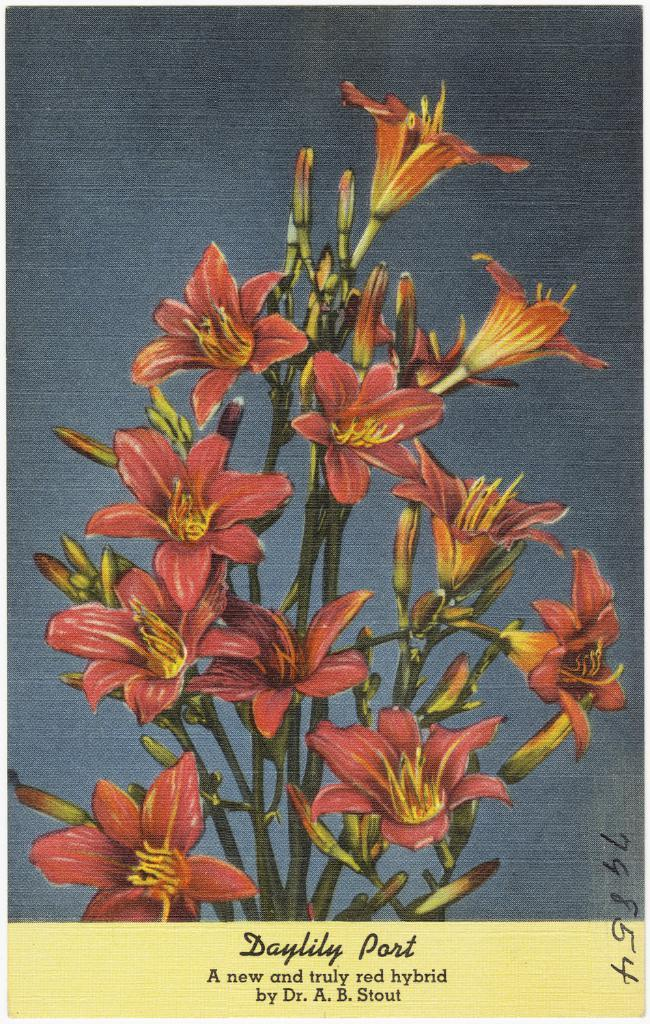What is the main subject of the painting in the image? The main subject of the painting in the image is flowers. What other plant-related item can be seen in the image? There is a plant in the image. Is there any text present in the image? Yes, there is some text at the bottom of the image. What type of quilt is being used to cover the plant in the image? There is no quilt present in the image; it features a painting of flowers and a plant. What plot of land is the plant growing on in the image? The image does not show a plot of land; it only shows a painting of flowers and a plant. 